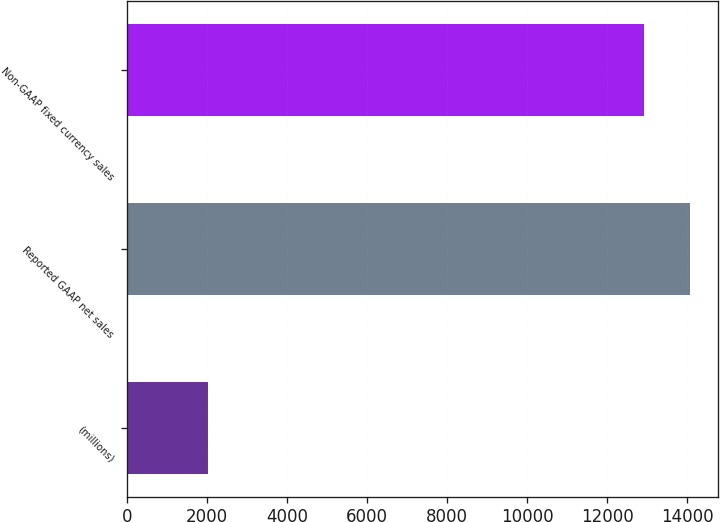<chart> <loc_0><loc_0><loc_500><loc_500><bar_chart><fcel>(millions)<fcel>Reported GAAP net sales<fcel>Non-GAAP fixed currency sales<nl><fcel>2015<fcel>14067.3<fcel>12914.3<nl></chart> 